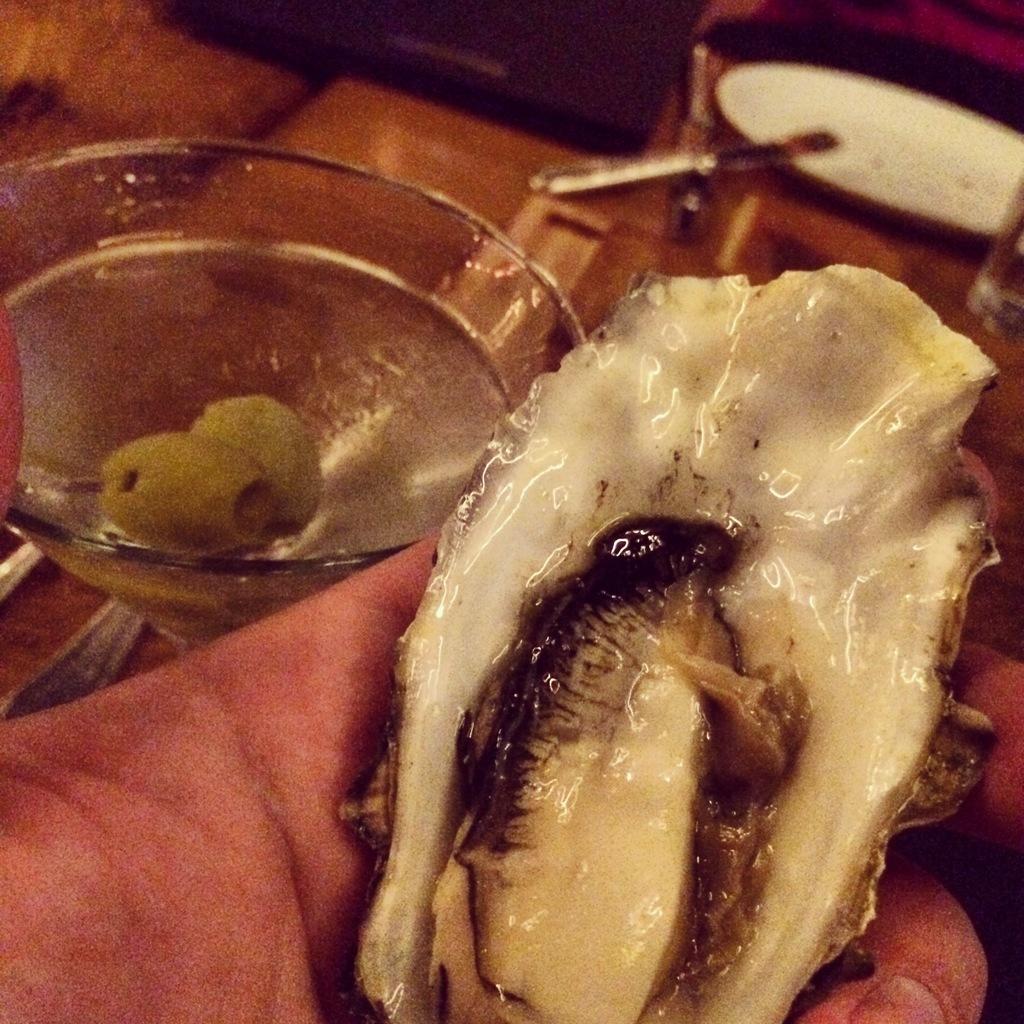Describe this image in one or two sentences. In this picture we can see a food on a person's hand, glass and in the background we can see some objects. 